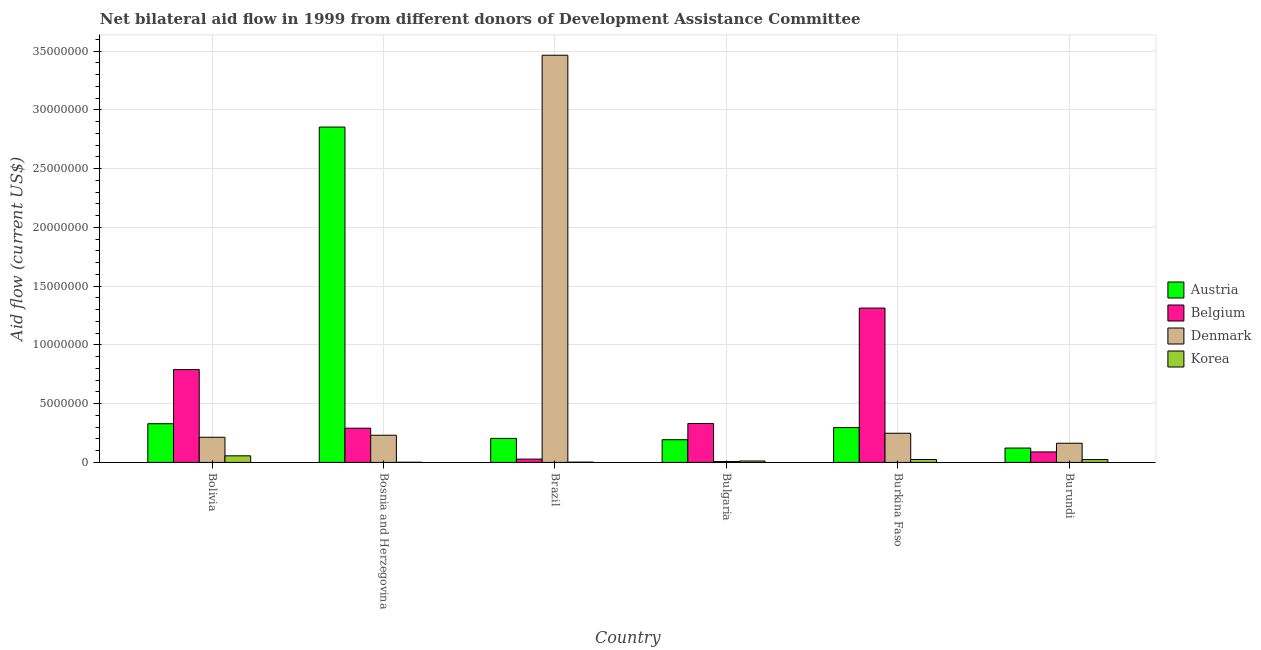How many different coloured bars are there?
Your response must be concise. 4. How many groups of bars are there?
Provide a short and direct response. 6. Are the number of bars per tick equal to the number of legend labels?
Your response must be concise. Yes. How many bars are there on the 6th tick from the left?
Keep it short and to the point. 4. What is the label of the 6th group of bars from the left?
Offer a very short reply. Burundi. In how many cases, is the number of bars for a given country not equal to the number of legend labels?
Ensure brevity in your answer.  0. What is the amount of aid given by belgium in Burundi?
Your answer should be very brief. 8.90e+05. Across all countries, what is the maximum amount of aid given by denmark?
Offer a very short reply. 3.46e+07. Across all countries, what is the minimum amount of aid given by korea?
Keep it short and to the point. 10000. In which country was the amount of aid given by belgium maximum?
Provide a succinct answer. Burkina Faso. In which country was the amount of aid given by belgium minimum?
Your answer should be very brief. Brazil. What is the total amount of aid given by austria in the graph?
Your response must be concise. 4.00e+07. What is the difference between the amount of aid given by belgium in Bulgaria and that in Burundi?
Make the answer very short. 2.42e+06. What is the difference between the amount of aid given by korea in Brazil and the amount of aid given by denmark in Bosnia and Herzegovina?
Keep it short and to the point. -2.29e+06. What is the average amount of aid given by korea per country?
Provide a short and direct response. 2.00e+05. What is the difference between the amount of aid given by belgium and amount of aid given by austria in Brazil?
Provide a short and direct response. -1.76e+06. In how many countries, is the amount of aid given by korea greater than 33000000 US$?
Give a very brief answer. 0. What is the ratio of the amount of aid given by belgium in Bulgaria to that in Burundi?
Your answer should be compact. 3.72. Is the difference between the amount of aid given by belgium in Brazil and Bulgaria greater than the difference between the amount of aid given by austria in Brazil and Bulgaria?
Provide a short and direct response. No. What is the difference between the highest and the second highest amount of aid given by austria?
Your answer should be very brief. 2.52e+07. What is the difference between the highest and the lowest amount of aid given by korea?
Ensure brevity in your answer.  5.50e+05. In how many countries, is the amount of aid given by belgium greater than the average amount of aid given by belgium taken over all countries?
Your response must be concise. 2. Is it the case that in every country, the sum of the amount of aid given by korea and amount of aid given by denmark is greater than the sum of amount of aid given by belgium and amount of aid given by austria?
Offer a terse response. No. What does the 1st bar from the right in Burundi represents?
Your response must be concise. Korea. Is it the case that in every country, the sum of the amount of aid given by austria and amount of aid given by belgium is greater than the amount of aid given by denmark?
Your answer should be compact. No. Are all the bars in the graph horizontal?
Offer a terse response. No. What is the difference between two consecutive major ticks on the Y-axis?
Your answer should be very brief. 5.00e+06. Are the values on the major ticks of Y-axis written in scientific E-notation?
Give a very brief answer. No. Does the graph contain any zero values?
Offer a terse response. No. Does the graph contain grids?
Keep it short and to the point. Yes. What is the title of the graph?
Give a very brief answer. Net bilateral aid flow in 1999 from different donors of Development Assistance Committee. Does "Financial sector" appear as one of the legend labels in the graph?
Keep it short and to the point. No. What is the label or title of the X-axis?
Your answer should be compact. Country. What is the label or title of the Y-axis?
Ensure brevity in your answer.  Aid flow (current US$). What is the Aid flow (current US$) in Austria in Bolivia?
Your answer should be very brief. 3.29e+06. What is the Aid flow (current US$) in Belgium in Bolivia?
Keep it short and to the point. 7.90e+06. What is the Aid flow (current US$) in Denmark in Bolivia?
Your answer should be very brief. 2.14e+06. What is the Aid flow (current US$) of Korea in Bolivia?
Offer a very short reply. 5.60e+05. What is the Aid flow (current US$) of Austria in Bosnia and Herzegovina?
Your response must be concise. 2.85e+07. What is the Aid flow (current US$) in Belgium in Bosnia and Herzegovina?
Your answer should be very brief. 2.91e+06. What is the Aid flow (current US$) in Denmark in Bosnia and Herzegovina?
Provide a short and direct response. 2.31e+06. What is the Aid flow (current US$) of Korea in Bosnia and Herzegovina?
Provide a succinct answer. 10000. What is the Aid flow (current US$) in Austria in Brazil?
Keep it short and to the point. 2.04e+06. What is the Aid flow (current US$) in Belgium in Brazil?
Provide a short and direct response. 2.80e+05. What is the Aid flow (current US$) in Denmark in Brazil?
Keep it short and to the point. 3.46e+07. What is the Aid flow (current US$) of Korea in Brazil?
Provide a succinct answer. 2.00e+04. What is the Aid flow (current US$) in Austria in Bulgaria?
Make the answer very short. 1.93e+06. What is the Aid flow (current US$) in Belgium in Bulgaria?
Provide a succinct answer. 3.31e+06. What is the Aid flow (current US$) of Korea in Bulgaria?
Ensure brevity in your answer.  1.20e+05. What is the Aid flow (current US$) of Austria in Burkina Faso?
Make the answer very short. 2.96e+06. What is the Aid flow (current US$) of Belgium in Burkina Faso?
Your response must be concise. 1.31e+07. What is the Aid flow (current US$) of Denmark in Burkina Faso?
Your answer should be very brief. 2.48e+06. What is the Aid flow (current US$) of Korea in Burkina Faso?
Provide a succinct answer. 2.50e+05. What is the Aid flow (current US$) of Austria in Burundi?
Your answer should be very brief. 1.22e+06. What is the Aid flow (current US$) in Belgium in Burundi?
Offer a very short reply. 8.90e+05. What is the Aid flow (current US$) in Denmark in Burundi?
Your answer should be compact. 1.63e+06. Across all countries, what is the maximum Aid flow (current US$) in Austria?
Provide a short and direct response. 2.85e+07. Across all countries, what is the maximum Aid flow (current US$) of Belgium?
Make the answer very short. 1.31e+07. Across all countries, what is the maximum Aid flow (current US$) of Denmark?
Your response must be concise. 3.46e+07. Across all countries, what is the maximum Aid flow (current US$) of Korea?
Keep it short and to the point. 5.60e+05. Across all countries, what is the minimum Aid flow (current US$) in Austria?
Give a very brief answer. 1.22e+06. Across all countries, what is the minimum Aid flow (current US$) of Belgium?
Make the answer very short. 2.80e+05. Across all countries, what is the minimum Aid flow (current US$) of Denmark?
Your response must be concise. 7.00e+04. What is the total Aid flow (current US$) in Austria in the graph?
Offer a very short reply. 4.00e+07. What is the total Aid flow (current US$) in Belgium in the graph?
Offer a terse response. 2.84e+07. What is the total Aid flow (current US$) in Denmark in the graph?
Provide a short and direct response. 4.33e+07. What is the total Aid flow (current US$) in Korea in the graph?
Provide a short and direct response. 1.20e+06. What is the difference between the Aid flow (current US$) of Austria in Bolivia and that in Bosnia and Herzegovina?
Your answer should be very brief. -2.52e+07. What is the difference between the Aid flow (current US$) of Belgium in Bolivia and that in Bosnia and Herzegovina?
Provide a short and direct response. 4.99e+06. What is the difference between the Aid flow (current US$) in Denmark in Bolivia and that in Bosnia and Herzegovina?
Offer a very short reply. -1.70e+05. What is the difference between the Aid flow (current US$) in Korea in Bolivia and that in Bosnia and Herzegovina?
Give a very brief answer. 5.50e+05. What is the difference between the Aid flow (current US$) of Austria in Bolivia and that in Brazil?
Your answer should be compact. 1.25e+06. What is the difference between the Aid flow (current US$) in Belgium in Bolivia and that in Brazil?
Give a very brief answer. 7.62e+06. What is the difference between the Aid flow (current US$) of Denmark in Bolivia and that in Brazil?
Ensure brevity in your answer.  -3.25e+07. What is the difference between the Aid flow (current US$) of Korea in Bolivia and that in Brazil?
Give a very brief answer. 5.40e+05. What is the difference between the Aid flow (current US$) in Austria in Bolivia and that in Bulgaria?
Ensure brevity in your answer.  1.36e+06. What is the difference between the Aid flow (current US$) in Belgium in Bolivia and that in Bulgaria?
Give a very brief answer. 4.59e+06. What is the difference between the Aid flow (current US$) of Denmark in Bolivia and that in Bulgaria?
Give a very brief answer. 2.07e+06. What is the difference between the Aid flow (current US$) in Korea in Bolivia and that in Bulgaria?
Your answer should be compact. 4.40e+05. What is the difference between the Aid flow (current US$) of Austria in Bolivia and that in Burkina Faso?
Make the answer very short. 3.30e+05. What is the difference between the Aid flow (current US$) of Belgium in Bolivia and that in Burkina Faso?
Ensure brevity in your answer.  -5.23e+06. What is the difference between the Aid flow (current US$) of Austria in Bolivia and that in Burundi?
Offer a terse response. 2.07e+06. What is the difference between the Aid flow (current US$) of Belgium in Bolivia and that in Burundi?
Your answer should be very brief. 7.01e+06. What is the difference between the Aid flow (current US$) in Denmark in Bolivia and that in Burundi?
Offer a very short reply. 5.10e+05. What is the difference between the Aid flow (current US$) in Austria in Bosnia and Herzegovina and that in Brazil?
Provide a succinct answer. 2.65e+07. What is the difference between the Aid flow (current US$) of Belgium in Bosnia and Herzegovina and that in Brazil?
Keep it short and to the point. 2.63e+06. What is the difference between the Aid flow (current US$) in Denmark in Bosnia and Herzegovina and that in Brazil?
Make the answer very short. -3.23e+07. What is the difference between the Aid flow (current US$) of Austria in Bosnia and Herzegovina and that in Bulgaria?
Offer a very short reply. 2.66e+07. What is the difference between the Aid flow (current US$) of Belgium in Bosnia and Herzegovina and that in Bulgaria?
Keep it short and to the point. -4.00e+05. What is the difference between the Aid flow (current US$) of Denmark in Bosnia and Herzegovina and that in Bulgaria?
Provide a short and direct response. 2.24e+06. What is the difference between the Aid flow (current US$) of Austria in Bosnia and Herzegovina and that in Burkina Faso?
Your response must be concise. 2.56e+07. What is the difference between the Aid flow (current US$) in Belgium in Bosnia and Herzegovina and that in Burkina Faso?
Offer a terse response. -1.02e+07. What is the difference between the Aid flow (current US$) of Denmark in Bosnia and Herzegovina and that in Burkina Faso?
Make the answer very short. -1.70e+05. What is the difference between the Aid flow (current US$) of Austria in Bosnia and Herzegovina and that in Burundi?
Ensure brevity in your answer.  2.73e+07. What is the difference between the Aid flow (current US$) of Belgium in Bosnia and Herzegovina and that in Burundi?
Give a very brief answer. 2.02e+06. What is the difference between the Aid flow (current US$) in Denmark in Bosnia and Herzegovina and that in Burundi?
Your answer should be compact. 6.80e+05. What is the difference between the Aid flow (current US$) in Austria in Brazil and that in Bulgaria?
Your answer should be compact. 1.10e+05. What is the difference between the Aid flow (current US$) in Belgium in Brazil and that in Bulgaria?
Offer a terse response. -3.03e+06. What is the difference between the Aid flow (current US$) in Denmark in Brazil and that in Bulgaria?
Give a very brief answer. 3.46e+07. What is the difference between the Aid flow (current US$) of Austria in Brazil and that in Burkina Faso?
Your answer should be very brief. -9.20e+05. What is the difference between the Aid flow (current US$) of Belgium in Brazil and that in Burkina Faso?
Keep it short and to the point. -1.28e+07. What is the difference between the Aid flow (current US$) of Denmark in Brazil and that in Burkina Faso?
Keep it short and to the point. 3.22e+07. What is the difference between the Aid flow (current US$) in Austria in Brazil and that in Burundi?
Give a very brief answer. 8.20e+05. What is the difference between the Aid flow (current US$) of Belgium in Brazil and that in Burundi?
Give a very brief answer. -6.10e+05. What is the difference between the Aid flow (current US$) in Denmark in Brazil and that in Burundi?
Ensure brevity in your answer.  3.30e+07. What is the difference between the Aid flow (current US$) of Austria in Bulgaria and that in Burkina Faso?
Your answer should be very brief. -1.03e+06. What is the difference between the Aid flow (current US$) of Belgium in Bulgaria and that in Burkina Faso?
Your response must be concise. -9.82e+06. What is the difference between the Aid flow (current US$) in Denmark in Bulgaria and that in Burkina Faso?
Offer a very short reply. -2.41e+06. What is the difference between the Aid flow (current US$) in Austria in Bulgaria and that in Burundi?
Keep it short and to the point. 7.10e+05. What is the difference between the Aid flow (current US$) of Belgium in Bulgaria and that in Burundi?
Your answer should be very brief. 2.42e+06. What is the difference between the Aid flow (current US$) in Denmark in Bulgaria and that in Burundi?
Keep it short and to the point. -1.56e+06. What is the difference between the Aid flow (current US$) of Korea in Bulgaria and that in Burundi?
Provide a succinct answer. -1.20e+05. What is the difference between the Aid flow (current US$) in Austria in Burkina Faso and that in Burundi?
Your answer should be compact. 1.74e+06. What is the difference between the Aid flow (current US$) in Belgium in Burkina Faso and that in Burundi?
Your answer should be compact. 1.22e+07. What is the difference between the Aid flow (current US$) in Denmark in Burkina Faso and that in Burundi?
Give a very brief answer. 8.50e+05. What is the difference between the Aid flow (current US$) in Korea in Burkina Faso and that in Burundi?
Your response must be concise. 10000. What is the difference between the Aid flow (current US$) in Austria in Bolivia and the Aid flow (current US$) in Denmark in Bosnia and Herzegovina?
Keep it short and to the point. 9.80e+05. What is the difference between the Aid flow (current US$) in Austria in Bolivia and the Aid flow (current US$) in Korea in Bosnia and Herzegovina?
Your answer should be very brief. 3.28e+06. What is the difference between the Aid flow (current US$) of Belgium in Bolivia and the Aid flow (current US$) of Denmark in Bosnia and Herzegovina?
Keep it short and to the point. 5.59e+06. What is the difference between the Aid flow (current US$) in Belgium in Bolivia and the Aid flow (current US$) in Korea in Bosnia and Herzegovina?
Provide a short and direct response. 7.89e+06. What is the difference between the Aid flow (current US$) in Denmark in Bolivia and the Aid flow (current US$) in Korea in Bosnia and Herzegovina?
Your response must be concise. 2.13e+06. What is the difference between the Aid flow (current US$) of Austria in Bolivia and the Aid flow (current US$) of Belgium in Brazil?
Give a very brief answer. 3.01e+06. What is the difference between the Aid flow (current US$) of Austria in Bolivia and the Aid flow (current US$) of Denmark in Brazil?
Provide a short and direct response. -3.14e+07. What is the difference between the Aid flow (current US$) in Austria in Bolivia and the Aid flow (current US$) in Korea in Brazil?
Give a very brief answer. 3.27e+06. What is the difference between the Aid flow (current US$) in Belgium in Bolivia and the Aid flow (current US$) in Denmark in Brazil?
Offer a terse response. -2.67e+07. What is the difference between the Aid flow (current US$) of Belgium in Bolivia and the Aid flow (current US$) of Korea in Brazil?
Make the answer very short. 7.88e+06. What is the difference between the Aid flow (current US$) of Denmark in Bolivia and the Aid flow (current US$) of Korea in Brazil?
Ensure brevity in your answer.  2.12e+06. What is the difference between the Aid flow (current US$) in Austria in Bolivia and the Aid flow (current US$) in Denmark in Bulgaria?
Ensure brevity in your answer.  3.22e+06. What is the difference between the Aid flow (current US$) of Austria in Bolivia and the Aid flow (current US$) of Korea in Bulgaria?
Your answer should be very brief. 3.17e+06. What is the difference between the Aid flow (current US$) in Belgium in Bolivia and the Aid flow (current US$) in Denmark in Bulgaria?
Keep it short and to the point. 7.83e+06. What is the difference between the Aid flow (current US$) in Belgium in Bolivia and the Aid flow (current US$) in Korea in Bulgaria?
Your answer should be compact. 7.78e+06. What is the difference between the Aid flow (current US$) of Denmark in Bolivia and the Aid flow (current US$) of Korea in Bulgaria?
Offer a very short reply. 2.02e+06. What is the difference between the Aid flow (current US$) of Austria in Bolivia and the Aid flow (current US$) of Belgium in Burkina Faso?
Offer a terse response. -9.84e+06. What is the difference between the Aid flow (current US$) of Austria in Bolivia and the Aid flow (current US$) of Denmark in Burkina Faso?
Give a very brief answer. 8.10e+05. What is the difference between the Aid flow (current US$) of Austria in Bolivia and the Aid flow (current US$) of Korea in Burkina Faso?
Your answer should be compact. 3.04e+06. What is the difference between the Aid flow (current US$) in Belgium in Bolivia and the Aid flow (current US$) in Denmark in Burkina Faso?
Your answer should be compact. 5.42e+06. What is the difference between the Aid flow (current US$) in Belgium in Bolivia and the Aid flow (current US$) in Korea in Burkina Faso?
Keep it short and to the point. 7.65e+06. What is the difference between the Aid flow (current US$) of Denmark in Bolivia and the Aid flow (current US$) of Korea in Burkina Faso?
Give a very brief answer. 1.89e+06. What is the difference between the Aid flow (current US$) of Austria in Bolivia and the Aid flow (current US$) of Belgium in Burundi?
Give a very brief answer. 2.40e+06. What is the difference between the Aid flow (current US$) in Austria in Bolivia and the Aid flow (current US$) in Denmark in Burundi?
Provide a succinct answer. 1.66e+06. What is the difference between the Aid flow (current US$) of Austria in Bolivia and the Aid flow (current US$) of Korea in Burundi?
Ensure brevity in your answer.  3.05e+06. What is the difference between the Aid flow (current US$) in Belgium in Bolivia and the Aid flow (current US$) in Denmark in Burundi?
Offer a terse response. 6.27e+06. What is the difference between the Aid flow (current US$) in Belgium in Bolivia and the Aid flow (current US$) in Korea in Burundi?
Ensure brevity in your answer.  7.66e+06. What is the difference between the Aid flow (current US$) of Denmark in Bolivia and the Aid flow (current US$) of Korea in Burundi?
Offer a terse response. 1.90e+06. What is the difference between the Aid flow (current US$) of Austria in Bosnia and Herzegovina and the Aid flow (current US$) of Belgium in Brazil?
Ensure brevity in your answer.  2.82e+07. What is the difference between the Aid flow (current US$) of Austria in Bosnia and Herzegovina and the Aid flow (current US$) of Denmark in Brazil?
Your response must be concise. -6.11e+06. What is the difference between the Aid flow (current US$) of Austria in Bosnia and Herzegovina and the Aid flow (current US$) of Korea in Brazil?
Your answer should be compact. 2.85e+07. What is the difference between the Aid flow (current US$) of Belgium in Bosnia and Herzegovina and the Aid flow (current US$) of Denmark in Brazil?
Provide a short and direct response. -3.17e+07. What is the difference between the Aid flow (current US$) of Belgium in Bosnia and Herzegovina and the Aid flow (current US$) of Korea in Brazil?
Provide a succinct answer. 2.89e+06. What is the difference between the Aid flow (current US$) of Denmark in Bosnia and Herzegovina and the Aid flow (current US$) of Korea in Brazil?
Provide a succinct answer. 2.29e+06. What is the difference between the Aid flow (current US$) in Austria in Bosnia and Herzegovina and the Aid flow (current US$) in Belgium in Bulgaria?
Provide a succinct answer. 2.52e+07. What is the difference between the Aid flow (current US$) of Austria in Bosnia and Herzegovina and the Aid flow (current US$) of Denmark in Bulgaria?
Make the answer very short. 2.85e+07. What is the difference between the Aid flow (current US$) in Austria in Bosnia and Herzegovina and the Aid flow (current US$) in Korea in Bulgaria?
Give a very brief answer. 2.84e+07. What is the difference between the Aid flow (current US$) in Belgium in Bosnia and Herzegovina and the Aid flow (current US$) in Denmark in Bulgaria?
Make the answer very short. 2.84e+06. What is the difference between the Aid flow (current US$) in Belgium in Bosnia and Herzegovina and the Aid flow (current US$) in Korea in Bulgaria?
Your answer should be very brief. 2.79e+06. What is the difference between the Aid flow (current US$) of Denmark in Bosnia and Herzegovina and the Aid flow (current US$) of Korea in Bulgaria?
Ensure brevity in your answer.  2.19e+06. What is the difference between the Aid flow (current US$) of Austria in Bosnia and Herzegovina and the Aid flow (current US$) of Belgium in Burkina Faso?
Your answer should be compact. 1.54e+07. What is the difference between the Aid flow (current US$) in Austria in Bosnia and Herzegovina and the Aid flow (current US$) in Denmark in Burkina Faso?
Give a very brief answer. 2.60e+07. What is the difference between the Aid flow (current US$) in Austria in Bosnia and Herzegovina and the Aid flow (current US$) in Korea in Burkina Faso?
Offer a very short reply. 2.83e+07. What is the difference between the Aid flow (current US$) in Belgium in Bosnia and Herzegovina and the Aid flow (current US$) in Korea in Burkina Faso?
Provide a succinct answer. 2.66e+06. What is the difference between the Aid flow (current US$) in Denmark in Bosnia and Herzegovina and the Aid flow (current US$) in Korea in Burkina Faso?
Ensure brevity in your answer.  2.06e+06. What is the difference between the Aid flow (current US$) in Austria in Bosnia and Herzegovina and the Aid flow (current US$) in Belgium in Burundi?
Your answer should be very brief. 2.76e+07. What is the difference between the Aid flow (current US$) in Austria in Bosnia and Herzegovina and the Aid flow (current US$) in Denmark in Burundi?
Keep it short and to the point. 2.69e+07. What is the difference between the Aid flow (current US$) of Austria in Bosnia and Herzegovina and the Aid flow (current US$) of Korea in Burundi?
Offer a very short reply. 2.83e+07. What is the difference between the Aid flow (current US$) of Belgium in Bosnia and Herzegovina and the Aid flow (current US$) of Denmark in Burundi?
Provide a succinct answer. 1.28e+06. What is the difference between the Aid flow (current US$) in Belgium in Bosnia and Herzegovina and the Aid flow (current US$) in Korea in Burundi?
Your answer should be compact. 2.67e+06. What is the difference between the Aid flow (current US$) of Denmark in Bosnia and Herzegovina and the Aid flow (current US$) of Korea in Burundi?
Your answer should be very brief. 2.07e+06. What is the difference between the Aid flow (current US$) in Austria in Brazil and the Aid flow (current US$) in Belgium in Bulgaria?
Ensure brevity in your answer.  -1.27e+06. What is the difference between the Aid flow (current US$) of Austria in Brazil and the Aid flow (current US$) of Denmark in Bulgaria?
Give a very brief answer. 1.97e+06. What is the difference between the Aid flow (current US$) in Austria in Brazil and the Aid flow (current US$) in Korea in Bulgaria?
Make the answer very short. 1.92e+06. What is the difference between the Aid flow (current US$) of Belgium in Brazil and the Aid flow (current US$) of Denmark in Bulgaria?
Your answer should be very brief. 2.10e+05. What is the difference between the Aid flow (current US$) in Denmark in Brazil and the Aid flow (current US$) in Korea in Bulgaria?
Give a very brief answer. 3.45e+07. What is the difference between the Aid flow (current US$) in Austria in Brazil and the Aid flow (current US$) in Belgium in Burkina Faso?
Make the answer very short. -1.11e+07. What is the difference between the Aid flow (current US$) of Austria in Brazil and the Aid flow (current US$) of Denmark in Burkina Faso?
Ensure brevity in your answer.  -4.40e+05. What is the difference between the Aid flow (current US$) of Austria in Brazil and the Aid flow (current US$) of Korea in Burkina Faso?
Give a very brief answer. 1.79e+06. What is the difference between the Aid flow (current US$) in Belgium in Brazil and the Aid flow (current US$) in Denmark in Burkina Faso?
Provide a short and direct response. -2.20e+06. What is the difference between the Aid flow (current US$) of Belgium in Brazil and the Aid flow (current US$) of Korea in Burkina Faso?
Your answer should be compact. 3.00e+04. What is the difference between the Aid flow (current US$) of Denmark in Brazil and the Aid flow (current US$) of Korea in Burkina Faso?
Keep it short and to the point. 3.44e+07. What is the difference between the Aid flow (current US$) in Austria in Brazil and the Aid flow (current US$) in Belgium in Burundi?
Offer a very short reply. 1.15e+06. What is the difference between the Aid flow (current US$) in Austria in Brazil and the Aid flow (current US$) in Korea in Burundi?
Make the answer very short. 1.80e+06. What is the difference between the Aid flow (current US$) of Belgium in Brazil and the Aid flow (current US$) of Denmark in Burundi?
Keep it short and to the point. -1.35e+06. What is the difference between the Aid flow (current US$) of Belgium in Brazil and the Aid flow (current US$) of Korea in Burundi?
Your response must be concise. 4.00e+04. What is the difference between the Aid flow (current US$) in Denmark in Brazil and the Aid flow (current US$) in Korea in Burundi?
Your answer should be very brief. 3.44e+07. What is the difference between the Aid flow (current US$) in Austria in Bulgaria and the Aid flow (current US$) in Belgium in Burkina Faso?
Provide a short and direct response. -1.12e+07. What is the difference between the Aid flow (current US$) of Austria in Bulgaria and the Aid flow (current US$) of Denmark in Burkina Faso?
Offer a very short reply. -5.50e+05. What is the difference between the Aid flow (current US$) in Austria in Bulgaria and the Aid flow (current US$) in Korea in Burkina Faso?
Offer a terse response. 1.68e+06. What is the difference between the Aid flow (current US$) in Belgium in Bulgaria and the Aid flow (current US$) in Denmark in Burkina Faso?
Make the answer very short. 8.30e+05. What is the difference between the Aid flow (current US$) in Belgium in Bulgaria and the Aid flow (current US$) in Korea in Burkina Faso?
Provide a succinct answer. 3.06e+06. What is the difference between the Aid flow (current US$) in Denmark in Bulgaria and the Aid flow (current US$) in Korea in Burkina Faso?
Ensure brevity in your answer.  -1.80e+05. What is the difference between the Aid flow (current US$) of Austria in Bulgaria and the Aid flow (current US$) of Belgium in Burundi?
Ensure brevity in your answer.  1.04e+06. What is the difference between the Aid flow (current US$) of Austria in Bulgaria and the Aid flow (current US$) of Korea in Burundi?
Provide a short and direct response. 1.69e+06. What is the difference between the Aid flow (current US$) in Belgium in Bulgaria and the Aid flow (current US$) in Denmark in Burundi?
Offer a terse response. 1.68e+06. What is the difference between the Aid flow (current US$) of Belgium in Bulgaria and the Aid flow (current US$) of Korea in Burundi?
Your answer should be very brief. 3.07e+06. What is the difference between the Aid flow (current US$) of Denmark in Bulgaria and the Aid flow (current US$) of Korea in Burundi?
Offer a terse response. -1.70e+05. What is the difference between the Aid flow (current US$) of Austria in Burkina Faso and the Aid flow (current US$) of Belgium in Burundi?
Make the answer very short. 2.07e+06. What is the difference between the Aid flow (current US$) of Austria in Burkina Faso and the Aid flow (current US$) of Denmark in Burundi?
Give a very brief answer. 1.33e+06. What is the difference between the Aid flow (current US$) of Austria in Burkina Faso and the Aid flow (current US$) of Korea in Burundi?
Offer a very short reply. 2.72e+06. What is the difference between the Aid flow (current US$) of Belgium in Burkina Faso and the Aid flow (current US$) of Denmark in Burundi?
Provide a short and direct response. 1.15e+07. What is the difference between the Aid flow (current US$) of Belgium in Burkina Faso and the Aid flow (current US$) of Korea in Burundi?
Offer a terse response. 1.29e+07. What is the difference between the Aid flow (current US$) of Denmark in Burkina Faso and the Aid flow (current US$) of Korea in Burundi?
Give a very brief answer. 2.24e+06. What is the average Aid flow (current US$) in Austria per country?
Offer a very short reply. 6.66e+06. What is the average Aid flow (current US$) of Belgium per country?
Your answer should be very brief. 4.74e+06. What is the average Aid flow (current US$) in Denmark per country?
Your response must be concise. 7.21e+06. What is the average Aid flow (current US$) of Korea per country?
Provide a succinct answer. 2.00e+05. What is the difference between the Aid flow (current US$) of Austria and Aid flow (current US$) of Belgium in Bolivia?
Provide a short and direct response. -4.61e+06. What is the difference between the Aid flow (current US$) in Austria and Aid flow (current US$) in Denmark in Bolivia?
Make the answer very short. 1.15e+06. What is the difference between the Aid flow (current US$) in Austria and Aid flow (current US$) in Korea in Bolivia?
Offer a very short reply. 2.73e+06. What is the difference between the Aid flow (current US$) in Belgium and Aid flow (current US$) in Denmark in Bolivia?
Offer a terse response. 5.76e+06. What is the difference between the Aid flow (current US$) in Belgium and Aid flow (current US$) in Korea in Bolivia?
Your answer should be compact. 7.34e+06. What is the difference between the Aid flow (current US$) in Denmark and Aid flow (current US$) in Korea in Bolivia?
Make the answer very short. 1.58e+06. What is the difference between the Aid flow (current US$) in Austria and Aid flow (current US$) in Belgium in Bosnia and Herzegovina?
Give a very brief answer. 2.56e+07. What is the difference between the Aid flow (current US$) of Austria and Aid flow (current US$) of Denmark in Bosnia and Herzegovina?
Provide a succinct answer. 2.62e+07. What is the difference between the Aid flow (current US$) of Austria and Aid flow (current US$) of Korea in Bosnia and Herzegovina?
Offer a terse response. 2.85e+07. What is the difference between the Aid flow (current US$) in Belgium and Aid flow (current US$) in Korea in Bosnia and Herzegovina?
Provide a succinct answer. 2.90e+06. What is the difference between the Aid flow (current US$) in Denmark and Aid flow (current US$) in Korea in Bosnia and Herzegovina?
Keep it short and to the point. 2.30e+06. What is the difference between the Aid flow (current US$) of Austria and Aid flow (current US$) of Belgium in Brazil?
Give a very brief answer. 1.76e+06. What is the difference between the Aid flow (current US$) of Austria and Aid flow (current US$) of Denmark in Brazil?
Make the answer very short. -3.26e+07. What is the difference between the Aid flow (current US$) of Austria and Aid flow (current US$) of Korea in Brazil?
Give a very brief answer. 2.02e+06. What is the difference between the Aid flow (current US$) in Belgium and Aid flow (current US$) in Denmark in Brazil?
Your answer should be compact. -3.44e+07. What is the difference between the Aid flow (current US$) in Denmark and Aid flow (current US$) in Korea in Brazil?
Make the answer very short. 3.46e+07. What is the difference between the Aid flow (current US$) in Austria and Aid flow (current US$) in Belgium in Bulgaria?
Your response must be concise. -1.38e+06. What is the difference between the Aid flow (current US$) in Austria and Aid flow (current US$) in Denmark in Bulgaria?
Make the answer very short. 1.86e+06. What is the difference between the Aid flow (current US$) of Austria and Aid flow (current US$) of Korea in Bulgaria?
Your answer should be compact. 1.81e+06. What is the difference between the Aid flow (current US$) of Belgium and Aid flow (current US$) of Denmark in Bulgaria?
Offer a very short reply. 3.24e+06. What is the difference between the Aid flow (current US$) in Belgium and Aid flow (current US$) in Korea in Bulgaria?
Provide a short and direct response. 3.19e+06. What is the difference between the Aid flow (current US$) in Denmark and Aid flow (current US$) in Korea in Bulgaria?
Ensure brevity in your answer.  -5.00e+04. What is the difference between the Aid flow (current US$) in Austria and Aid flow (current US$) in Belgium in Burkina Faso?
Offer a terse response. -1.02e+07. What is the difference between the Aid flow (current US$) of Austria and Aid flow (current US$) of Korea in Burkina Faso?
Offer a terse response. 2.71e+06. What is the difference between the Aid flow (current US$) of Belgium and Aid flow (current US$) of Denmark in Burkina Faso?
Ensure brevity in your answer.  1.06e+07. What is the difference between the Aid flow (current US$) in Belgium and Aid flow (current US$) in Korea in Burkina Faso?
Give a very brief answer. 1.29e+07. What is the difference between the Aid flow (current US$) of Denmark and Aid flow (current US$) of Korea in Burkina Faso?
Provide a short and direct response. 2.23e+06. What is the difference between the Aid flow (current US$) of Austria and Aid flow (current US$) of Belgium in Burundi?
Provide a succinct answer. 3.30e+05. What is the difference between the Aid flow (current US$) of Austria and Aid flow (current US$) of Denmark in Burundi?
Your answer should be compact. -4.10e+05. What is the difference between the Aid flow (current US$) of Austria and Aid flow (current US$) of Korea in Burundi?
Offer a terse response. 9.80e+05. What is the difference between the Aid flow (current US$) in Belgium and Aid flow (current US$) in Denmark in Burundi?
Offer a terse response. -7.40e+05. What is the difference between the Aid flow (current US$) in Belgium and Aid flow (current US$) in Korea in Burundi?
Your answer should be compact. 6.50e+05. What is the difference between the Aid flow (current US$) in Denmark and Aid flow (current US$) in Korea in Burundi?
Offer a terse response. 1.39e+06. What is the ratio of the Aid flow (current US$) in Austria in Bolivia to that in Bosnia and Herzegovina?
Give a very brief answer. 0.12. What is the ratio of the Aid flow (current US$) of Belgium in Bolivia to that in Bosnia and Herzegovina?
Your answer should be compact. 2.71. What is the ratio of the Aid flow (current US$) of Denmark in Bolivia to that in Bosnia and Herzegovina?
Provide a succinct answer. 0.93. What is the ratio of the Aid flow (current US$) of Korea in Bolivia to that in Bosnia and Herzegovina?
Provide a succinct answer. 56. What is the ratio of the Aid flow (current US$) in Austria in Bolivia to that in Brazil?
Your answer should be very brief. 1.61. What is the ratio of the Aid flow (current US$) in Belgium in Bolivia to that in Brazil?
Offer a terse response. 28.21. What is the ratio of the Aid flow (current US$) of Denmark in Bolivia to that in Brazil?
Make the answer very short. 0.06. What is the ratio of the Aid flow (current US$) in Korea in Bolivia to that in Brazil?
Offer a terse response. 28. What is the ratio of the Aid flow (current US$) of Austria in Bolivia to that in Bulgaria?
Provide a succinct answer. 1.7. What is the ratio of the Aid flow (current US$) in Belgium in Bolivia to that in Bulgaria?
Your answer should be compact. 2.39. What is the ratio of the Aid flow (current US$) in Denmark in Bolivia to that in Bulgaria?
Ensure brevity in your answer.  30.57. What is the ratio of the Aid flow (current US$) of Korea in Bolivia to that in Bulgaria?
Keep it short and to the point. 4.67. What is the ratio of the Aid flow (current US$) in Austria in Bolivia to that in Burkina Faso?
Your response must be concise. 1.11. What is the ratio of the Aid flow (current US$) of Belgium in Bolivia to that in Burkina Faso?
Provide a succinct answer. 0.6. What is the ratio of the Aid flow (current US$) of Denmark in Bolivia to that in Burkina Faso?
Give a very brief answer. 0.86. What is the ratio of the Aid flow (current US$) in Korea in Bolivia to that in Burkina Faso?
Ensure brevity in your answer.  2.24. What is the ratio of the Aid flow (current US$) of Austria in Bolivia to that in Burundi?
Provide a short and direct response. 2.7. What is the ratio of the Aid flow (current US$) of Belgium in Bolivia to that in Burundi?
Your answer should be compact. 8.88. What is the ratio of the Aid flow (current US$) of Denmark in Bolivia to that in Burundi?
Your response must be concise. 1.31. What is the ratio of the Aid flow (current US$) in Korea in Bolivia to that in Burundi?
Offer a very short reply. 2.33. What is the ratio of the Aid flow (current US$) of Austria in Bosnia and Herzegovina to that in Brazil?
Make the answer very short. 13.99. What is the ratio of the Aid flow (current US$) of Belgium in Bosnia and Herzegovina to that in Brazil?
Ensure brevity in your answer.  10.39. What is the ratio of the Aid flow (current US$) of Denmark in Bosnia and Herzegovina to that in Brazil?
Offer a very short reply. 0.07. What is the ratio of the Aid flow (current US$) in Korea in Bosnia and Herzegovina to that in Brazil?
Make the answer very short. 0.5. What is the ratio of the Aid flow (current US$) of Austria in Bosnia and Herzegovina to that in Bulgaria?
Your response must be concise. 14.78. What is the ratio of the Aid flow (current US$) of Belgium in Bosnia and Herzegovina to that in Bulgaria?
Provide a short and direct response. 0.88. What is the ratio of the Aid flow (current US$) of Denmark in Bosnia and Herzegovina to that in Bulgaria?
Provide a succinct answer. 33. What is the ratio of the Aid flow (current US$) in Korea in Bosnia and Herzegovina to that in Bulgaria?
Your response must be concise. 0.08. What is the ratio of the Aid flow (current US$) of Austria in Bosnia and Herzegovina to that in Burkina Faso?
Provide a succinct answer. 9.64. What is the ratio of the Aid flow (current US$) in Belgium in Bosnia and Herzegovina to that in Burkina Faso?
Offer a very short reply. 0.22. What is the ratio of the Aid flow (current US$) of Denmark in Bosnia and Herzegovina to that in Burkina Faso?
Give a very brief answer. 0.93. What is the ratio of the Aid flow (current US$) of Austria in Bosnia and Herzegovina to that in Burundi?
Keep it short and to the point. 23.39. What is the ratio of the Aid flow (current US$) of Belgium in Bosnia and Herzegovina to that in Burundi?
Give a very brief answer. 3.27. What is the ratio of the Aid flow (current US$) in Denmark in Bosnia and Herzegovina to that in Burundi?
Your answer should be compact. 1.42. What is the ratio of the Aid flow (current US$) in Korea in Bosnia and Herzegovina to that in Burundi?
Give a very brief answer. 0.04. What is the ratio of the Aid flow (current US$) of Austria in Brazil to that in Bulgaria?
Your response must be concise. 1.06. What is the ratio of the Aid flow (current US$) in Belgium in Brazil to that in Bulgaria?
Keep it short and to the point. 0.08. What is the ratio of the Aid flow (current US$) of Denmark in Brazil to that in Bulgaria?
Offer a very short reply. 494.86. What is the ratio of the Aid flow (current US$) of Austria in Brazil to that in Burkina Faso?
Ensure brevity in your answer.  0.69. What is the ratio of the Aid flow (current US$) in Belgium in Brazil to that in Burkina Faso?
Keep it short and to the point. 0.02. What is the ratio of the Aid flow (current US$) of Denmark in Brazil to that in Burkina Faso?
Your answer should be very brief. 13.97. What is the ratio of the Aid flow (current US$) of Korea in Brazil to that in Burkina Faso?
Keep it short and to the point. 0.08. What is the ratio of the Aid flow (current US$) of Austria in Brazil to that in Burundi?
Provide a short and direct response. 1.67. What is the ratio of the Aid flow (current US$) of Belgium in Brazil to that in Burundi?
Provide a short and direct response. 0.31. What is the ratio of the Aid flow (current US$) in Denmark in Brazil to that in Burundi?
Your response must be concise. 21.25. What is the ratio of the Aid flow (current US$) in Korea in Brazil to that in Burundi?
Ensure brevity in your answer.  0.08. What is the ratio of the Aid flow (current US$) of Austria in Bulgaria to that in Burkina Faso?
Keep it short and to the point. 0.65. What is the ratio of the Aid flow (current US$) in Belgium in Bulgaria to that in Burkina Faso?
Provide a succinct answer. 0.25. What is the ratio of the Aid flow (current US$) in Denmark in Bulgaria to that in Burkina Faso?
Provide a succinct answer. 0.03. What is the ratio of the Aid flow (current US$) in Korea in Bulgaria to that in Burkina Faso?
Keep it short and to the point. 0.48. What is the ratio of the Aid flow (current US$) of Austria in Bulgaria to that in Burundi?
Provide a succinct answer. 1.58. What is the ratio of the Aid flow (current US$) of Belgium in Bulgaria to that in Burundi?
Provide a short and direct response. 3.72. What is the ratio of the Aid flow (current US$) in Denmark in Bulgaria to that in Burundi?
Ensure brevity in your answer.  0.04. What is the ratio of the Aid flow (current US$) of Austria in Burkina Faso to that in Burundi?
Make the answer very short. 2.43. What is the ratio of the Aid flow (current US$) of Belgium in Burkina Faso to that in Burundi?
Your answer should be very brief. 14.75. What is the ratio of the Aid flow (current US$) of Denmark in Burkina Faso to that in Burundi?
Provide a succinct answer. 1.52. What is the ratio of the Aid flow (current US$) in Korea in Burkina Faso to that in Burundi?
Give a very brief answer. 1.04. What is the difference between the highest and the second highest Aid flow (current US$) of Austria?
Offer a very short reply. 2.52e+07. What is the difference between the highest and the second highest Aid flow (current US$) in Belgium?
Keep it short and to the point. 5.23e+06. What is the difference between the highest and the second highest Aid flow (current US$) of Denmark?
Offer a terse response. 3.22e+07. What is the difference between the highest and the lowest Aid flow (current US$) of Austria?
Ensure brevity in your answer.  2.73e+07. What is the difference between the highest and the lowest Aid flow (current US$) in Belgium?
Offer a terse response. 1.28e+07. What is the difference between the highest and the lowest Aid flow (current US$) of Denmark?
Offer a very short reply. 3.46e+07. 